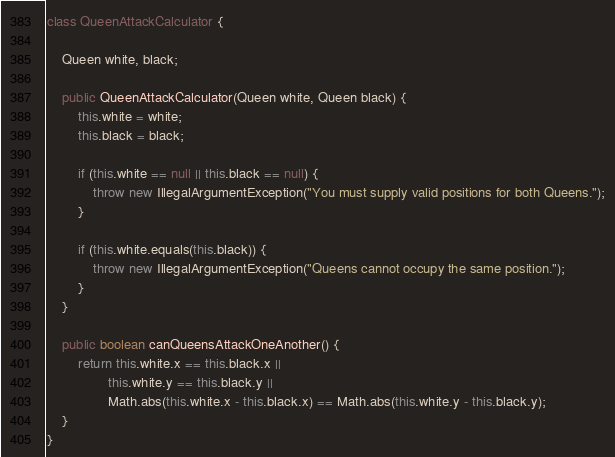Convert code to text. <code><loc_0><loc_0><loc_500><loc_500><_Java_>class QueenAttackCalculator {

    Queen white, black;

    public QueenAttackCalculator(Queen white, Queen black) {
        this.white = white;
        this.black = black;

        if (this.white == null || this.black == null) {
            throw new IllegalArgumentException("You must supply valid positions for both Queens.");
        }

        if (this.white.equals(this.black)) {
            throw new IllegalArgumentException("Queens cannot occupy the same position.");
        }
    }

    public boolean canQueensAttackOneAnother() {
        return this.white.x == this.black.x ||
                this.white.y == this.black.y ||
                Math.abs(this.white.x - this.black.x) == Math.abs(this.white.y - this.black.y);
    }
}</code> 